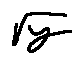Convert formula to latex. <formula><loc_0><loc_0><loc_500><loc_500>\sqrt { y }</formula> 